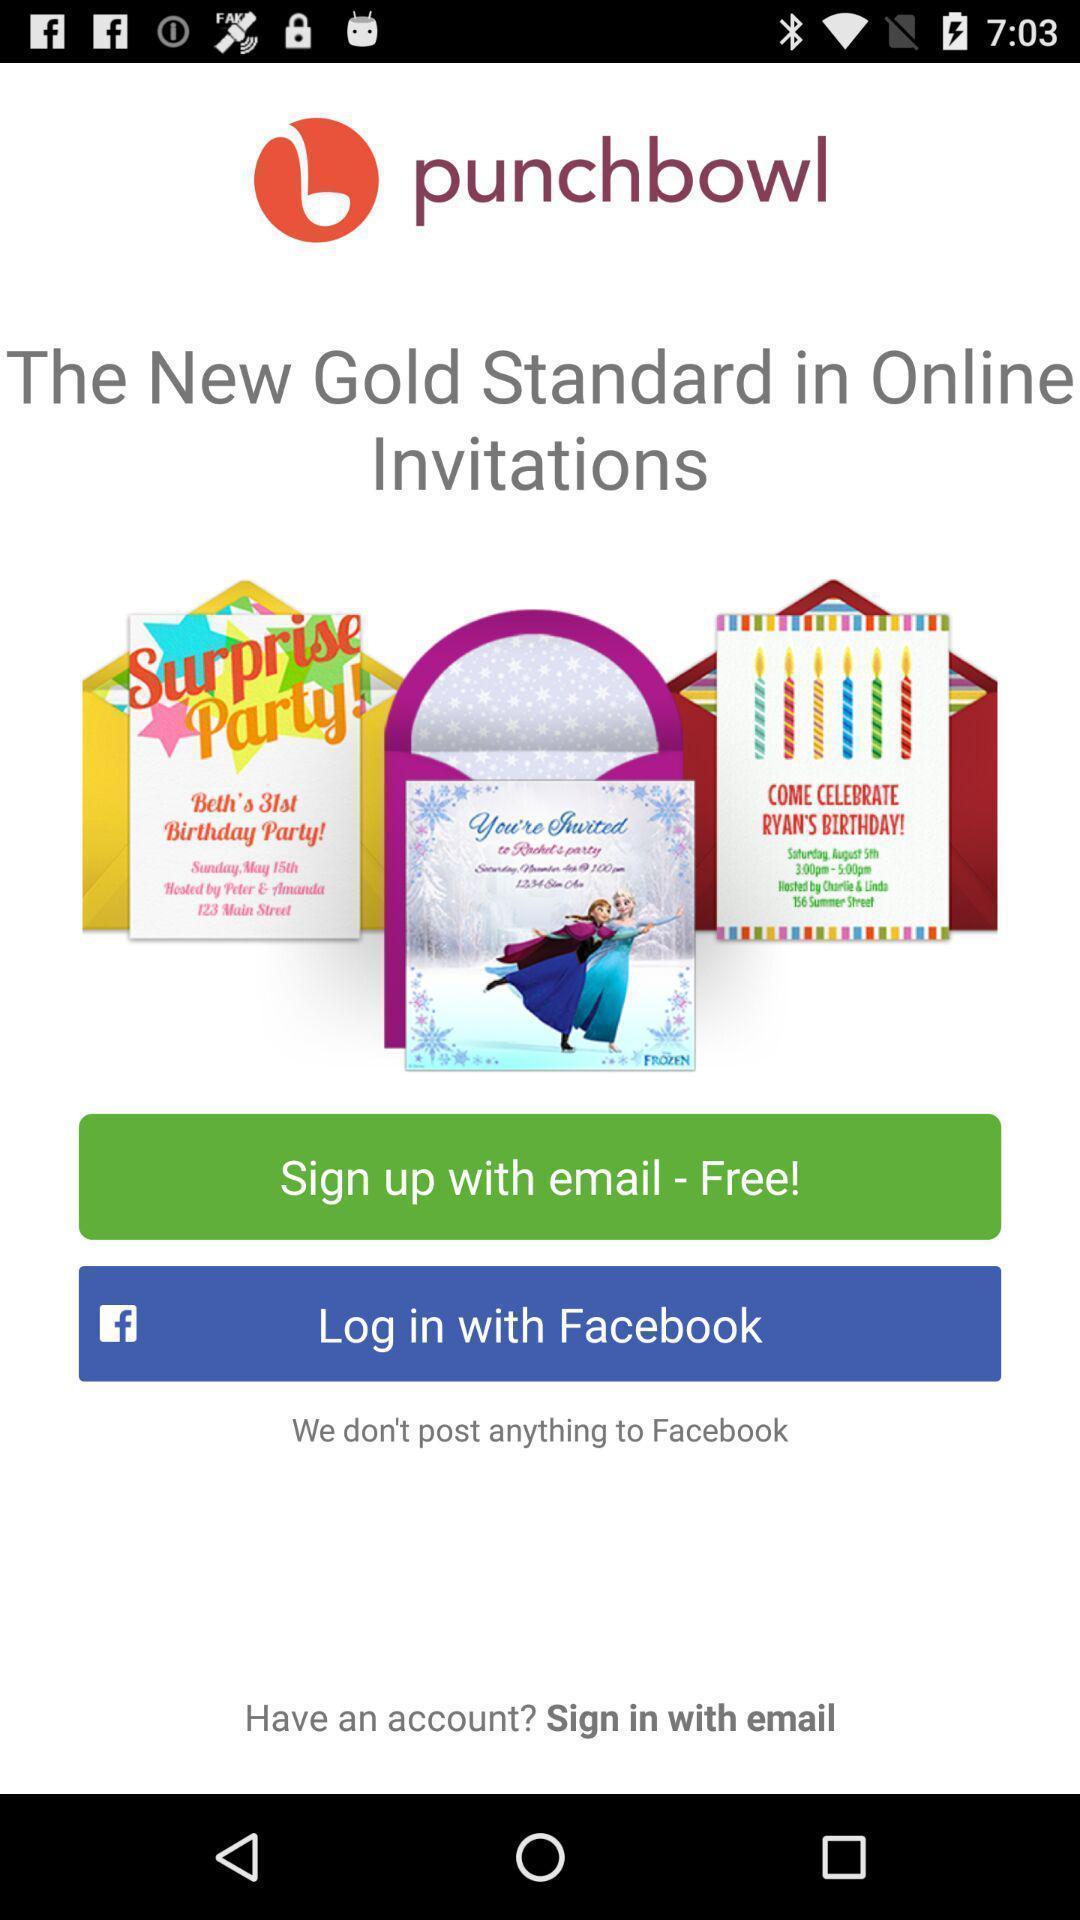Provide a textual representation of this image. Welcome and log-in page for an application. 